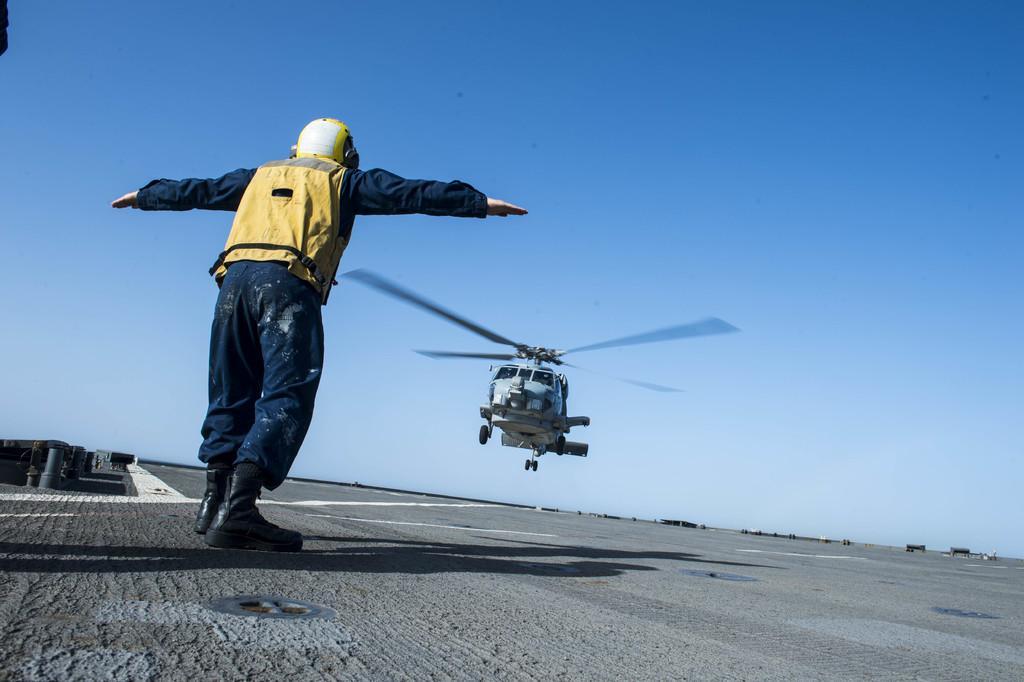How would you summarize this image in a sentence or two? In this picture we can see one plane is flying from the runway, in front one person is standing and stretching hands. 